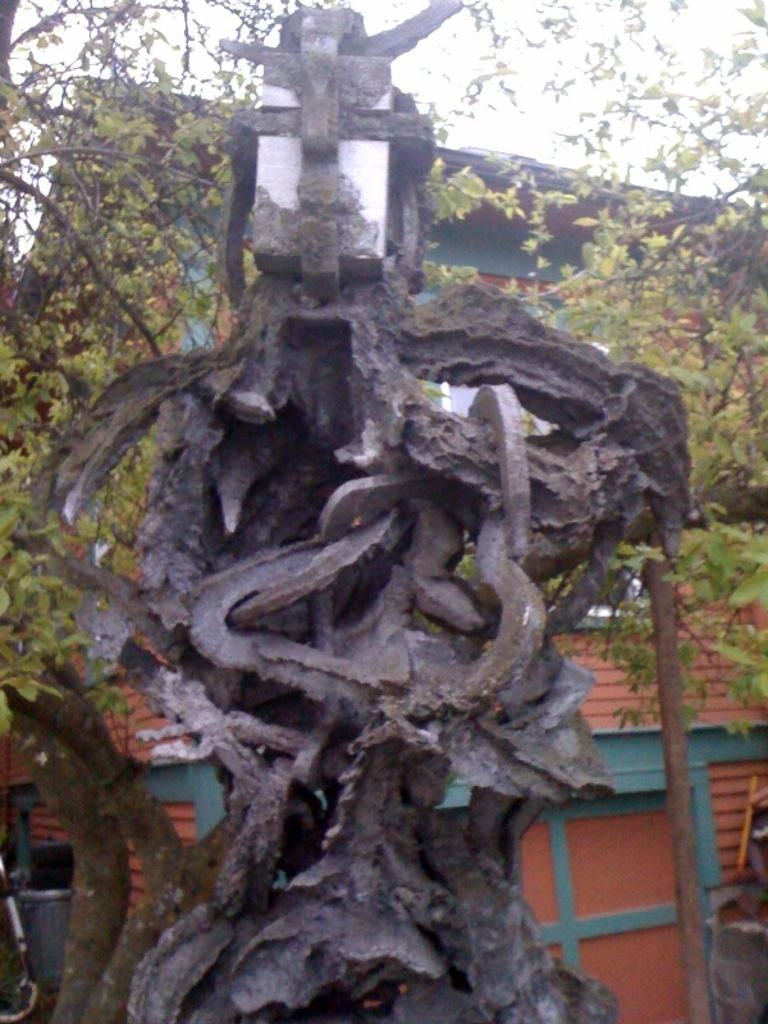What type of plant can be seen in the image? There is a tree in the image. What structure is located behind the tree? There is a house behind the tree. What color is the house? The house is red. What part of the house shares the same color as the house itself? The roof of the house is red. What is visible at the top of the image? The sky is visible at the top of the image. What type of net is being used to catch the apples from the tree in the image? There is no net present in the image, and no apples are mentioned. 